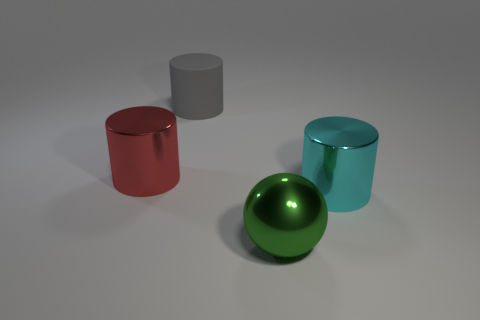Subtract all big metal cylinders. How many cylinders are left? 1 Add 4 metal spheres. How many objects exist? 8 Subtract all red cylinders. How many cylinders are left? 2 Subtract 0 blue spheres. How many objects are left? 4 Subtract all balls. How many objects are left? 3 Subtract 2 cylinders. How many cylinders are left? 1 Subtract all yellow cylinders. Subtract all cyan balls. How many cylinders are left? 3 Subtract all large things. Subtract all large red spheres. How many objects are left? 0 Add 3 shiny things. How many shiny things are left? 6 Add 4 large things. How many large things exist? 8 